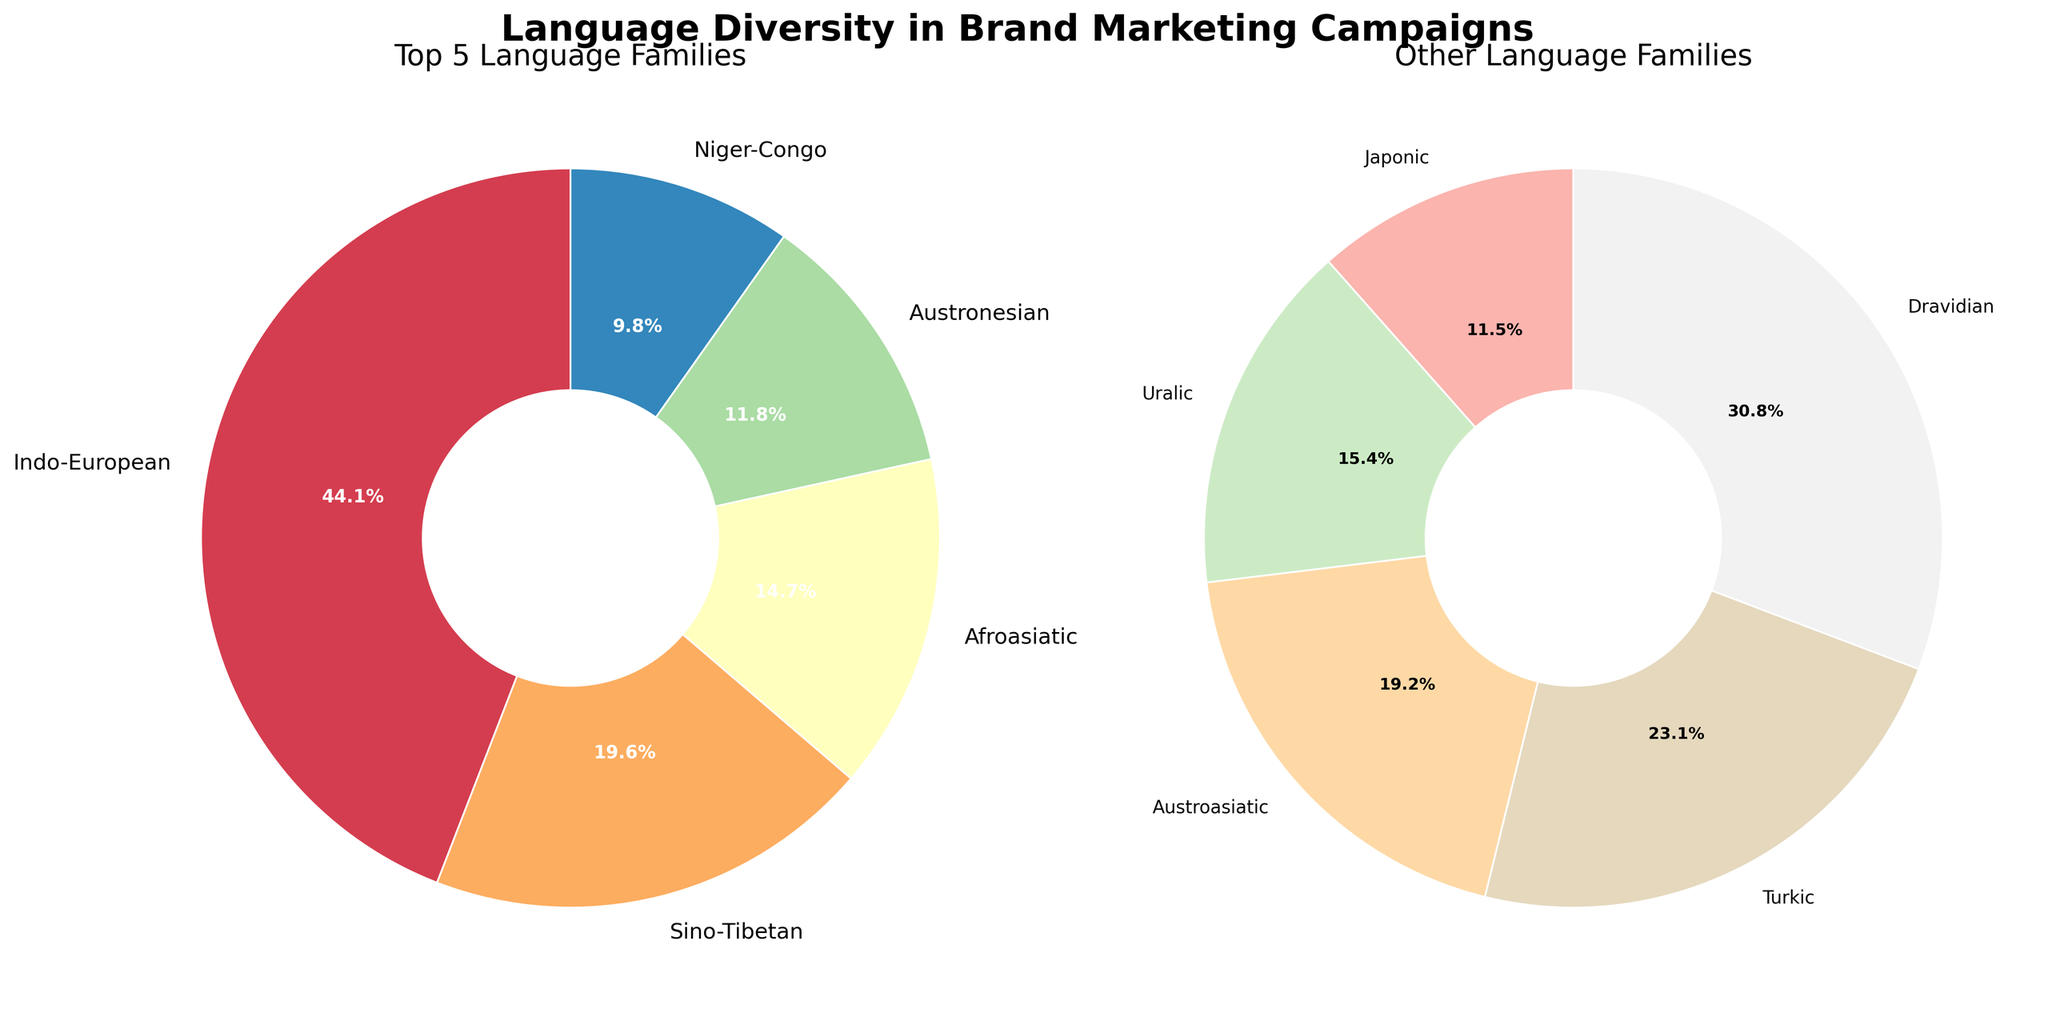What is the title of the figure? The title of the figure is written in a large, bold font above the subplots. It reads "Language Diversity in Brand Marketing Campaigns".
Answer: Language Diversity in Brand Marketing Campaigns Which language family has the highest campaign count in the top 5 chart? In the pie chart on the left titled 'Top 5 Language Families', the largest section represents Indo-European with the highest campaign count of 45.
Answer: Indo-European How many language families are depicted in the 'Other Language Families' chart? The pie chart on the right titled 'Other Language Families' has multiple colored sections, each representing a language family. Counting these sections gives 5 language families.
Answer: 5 What percentage of campaigns are in the Sino-Tibetan language family? In the 'Top 5 Language Families' pie chart on the left, the Sino-Tibetan segment is labeled with its percentage, which is 20.
Answer: 20% How does the campaign count of the Niger-Congo language family compare to the Dravidian language family? In the 'Other Language Families' chart, the Niger-Congo family has 10 campaigns, while the Dravidian family has 8 campaigns. Niger-Congo has 2 more campaigns.
Answer: Niger-Congo has 2 more What is the combined campaign count of the top three language families? The top three language families in the left chart are Indo-European (45), Sino-Tibetan (20), and Afroasiatic (15). Adding them together gives 45 + 20 + 15 = 80.
Answer: 80 Which language family has the smallest campaign count in the 'Other Language Families' chart? In the 'Other Language Families' donut chart, the Japonic family, represented by the smallest section, has the campaign count of 3.
Answer: Japonic What percentage of campaigns are in language families outside the top 5? The right pie chart shows the percentages for the 'Other Language Families'. Summing up these percentages gives the overall percentage for the families outside the top 5. The sum of the percentages in the left chart can also be subtracted from 100%.
Answer: 36% Between the Austronesian and Dravidian language families, which has a higher campaign count and by how much? In the charts, the Austronesian family has 12 campaigns and the Dravidian family has 8 campaigns. Austronesian has 4 more campaigns.
Answer: Austronesian by 4 What is the average campaign count of the language families in the 'Other Language Families' chart? The chart on the right includes language families with campaign counts of 10, 8, 6, 5, and 4. Adding these counts and dividing by the number of families gives (10 + 8 + 6 + 5 + 4) / 5 = 6.6.
Answer: 6.6 